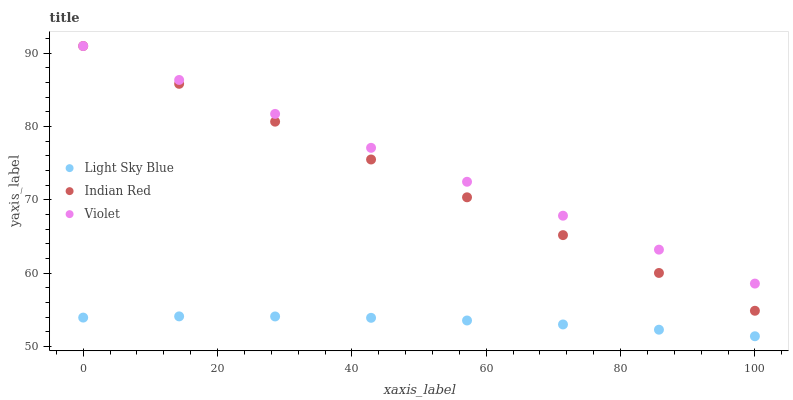Does Light Sky Blue have the minimum area under the curve?
Answer yes or no. Yes. Does Violet have the maximum area under the curve?
Answer yes or no. Yes. Does Indian Red have the minimum area under the curve?
Answer yes or no. No. Does Indian Red have the maximum area under the curve?
Answer yes or no. No. Is Indian Red the smoothest?
Answer yes or no. Yes. Is Light Sky Blue the roughest?
Answer yes or no. Yes. Is Violet the smoothest?
Answer yes or no. No. Is Violet the roughest?
Answer yes or no. No. Does Light Sky Blue have the lowest value?
Answer yes or no. Yes. Does Indian Red have the lowest value?
Answer yes or no. No. Does Violet have the highest value?
Answer yes or no. Yes. Is Light Sky Blue less than Violet?
Answer yes or no. Yes. Is Indian Red greater than Light Sky Blue?
Answer yes or no. Yes. Does Violet intersect Indian Red?
Answer yes or no. Yes. Is Violet less than Indian Red?
Answer yes or no. No. Is Violet greater than Indian Red?
Answer yes or no. No. Does Light Sky Blue intersect Violet?
Answer yes or no. No. 